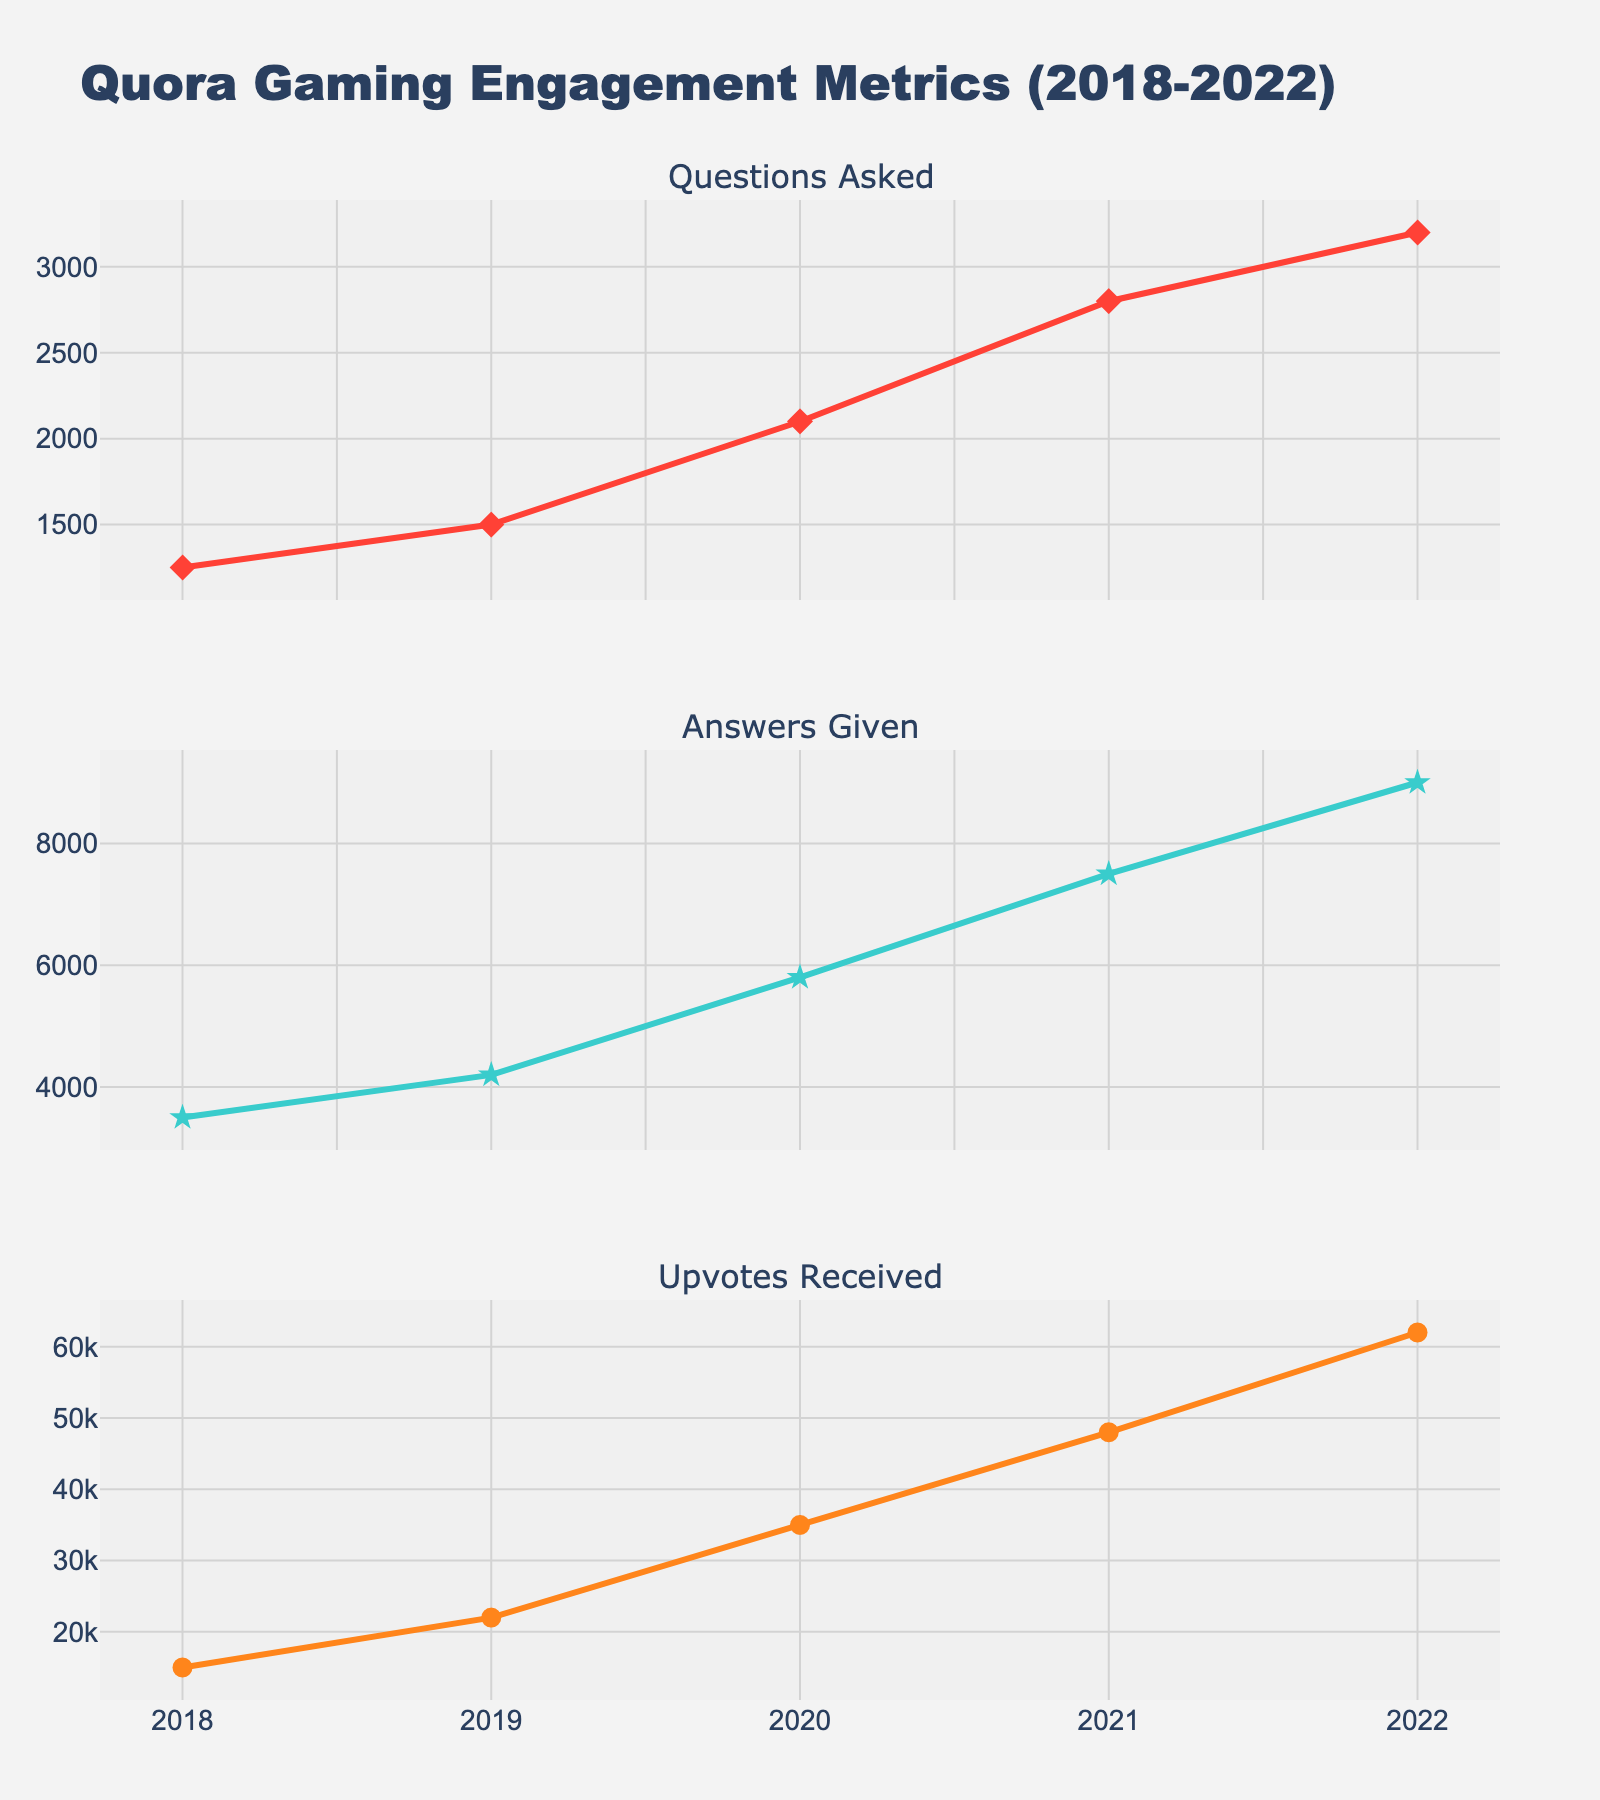What is the title of the figure? The title of the figure is positioned at the top and clearly states the overall context of the data being visualized. You can read it from the title element.
Answer: Quora Gaming Engagement Metrics (2018-2022) How many subplots are there in the figure? The figure is organized into multiple sections that focus on different metrics. Each section is a subplot. You can count the number of distinct sections or subplot titles.
Answer: Three Which year had the highest number of questions asked? Look at the line chart for the "Questions Asked" subplot and identify the data point that reaches the highest value on the y-axis, then trace it back to the corresponding year on the x-axis.
Answer: 2022 What is the difference in the number of upvotes received between 2020 and 2021? First, locate the data points for upvotes received in 2020 and 2021 on the "Upvotes Received" subplot. Then subtract the value of 2020 from the value of 2021.
Answer: 13,000 By how much did the answers given increase from 2018 to 2019? Find the points for answers given in 2018 and 2019 from the "Answers Given" subplot. Subtract the value in 2018 from the value in 2019 to get the increase.
Answer: 700 Which year saw the greatest increase in upvotes received compared to the previous year? To determine the year with the greatest increase, calculate the year-over-year differences in upvotes received by finding the differences between consecutive data points on the "Upvotes Received" subplot. Compare these differences to find the maximum.
Answer: 2019 What is the average number of questions asked per year over the entire period? Add up all the values for questions asked from 2018 to 2022, then divide the total by the number of years (5).
Answer: 2,170 In which subplot does the data show a continuous increase every year? Examine the trends in each of the three subplots. Identify the one that shows an uninterrupted upward trend across all data points from 2018 to 2022.
Answer: Upvotes Received Which metric had the lowest value in 2018? Compare the initial data points (2018 values) for all three metrics: Questions Asked, Answers Given, and Upvotes Received. The lowest value will be evident among these.
Answer: Answers Given 